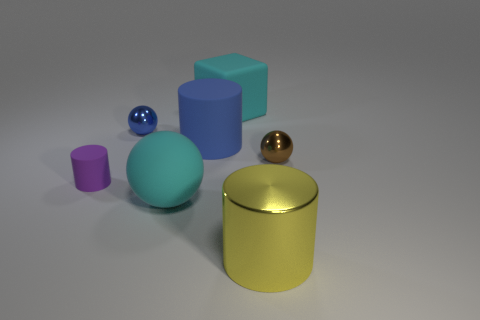Are there any blocks of the same color as the large ball?
Give a very brief answer. Yes. What size is the matte block that is the same color as the large rubber ball?
Offer a terse response. Large. There is a big thing that is the same color as the block; what is its shape?
Keep it short and to the point. Sphere. There is a large thing to the right of the big cyan object that is behind the small purple cylinder; what shape is it?
Your response must be concise. Cylinder. Are there more balls that are right of the big rubber block than big brown matte things?
Keep it short and to the point. Yes. There is a cyan thing on the left side of the big cyan matte cube; is its shape the same as the small brown metallic thing?
Offer a terse response. Yes. Are there any other blue objects of the same shape as the large shiny object?
Ensure brevity in your answer.  Yes. How many objects are shiny spheres that are right of the blue matte cylinder or large metal spheres?
Your response must be concise. 1. Is the number of rubber spheres greater than the number of large matte objects?
Keep it short and to the point. No. Are there any spheres of the same size as the blue matte cylinder?
Ensure brevity in your answer.  Yes. 